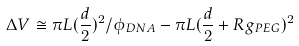Convert formula to latex. <formula><loc_0><loc_0><loc_500><loc_500>\Delta V \cong \pi L ( \frac { d } { 2 } ) ^ { 2 } / \phi _ { D N A } - \pi L ( \frac { d } { 2 } + R g _ { P E G } ) ^ { 2 }</formula> 